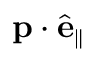Convert formula to latex. <formula><loc_0><loc_0><loc_500><loc_500>p \cdot \hat { e } _ { \| }</formula> 